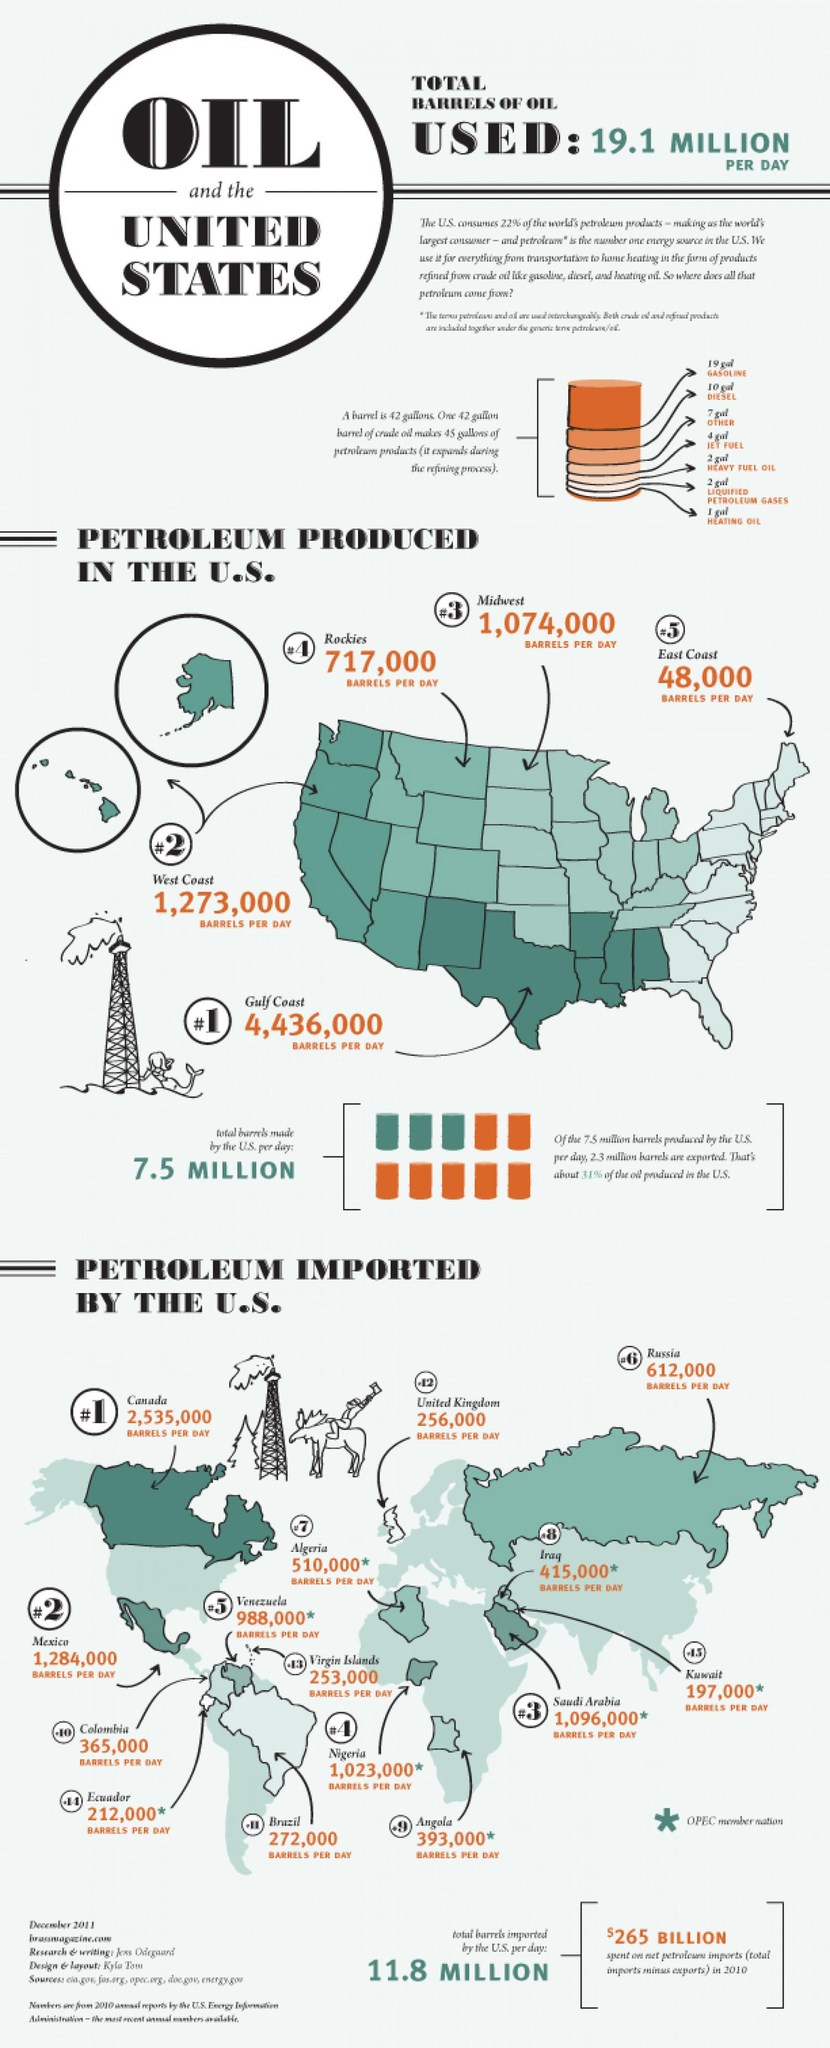Outline some significant characteristics in this image. The barrels produced per day differ between the Rockies and East Coast, with the Rockies producing 669,000 barrels per day. The difference in barrels produced per day between the West Coast and Midwest is approximately 199,000. A daily average of 4,915,000 barrels of crude oil are exported from Canada, Mexico, and Saudi Arabia to the United States. Thirteen countries export petroleum to the United States. As of 2021, the total number of barrels imported by the United States and the number of barrels produced by the US is 19.3 million. 